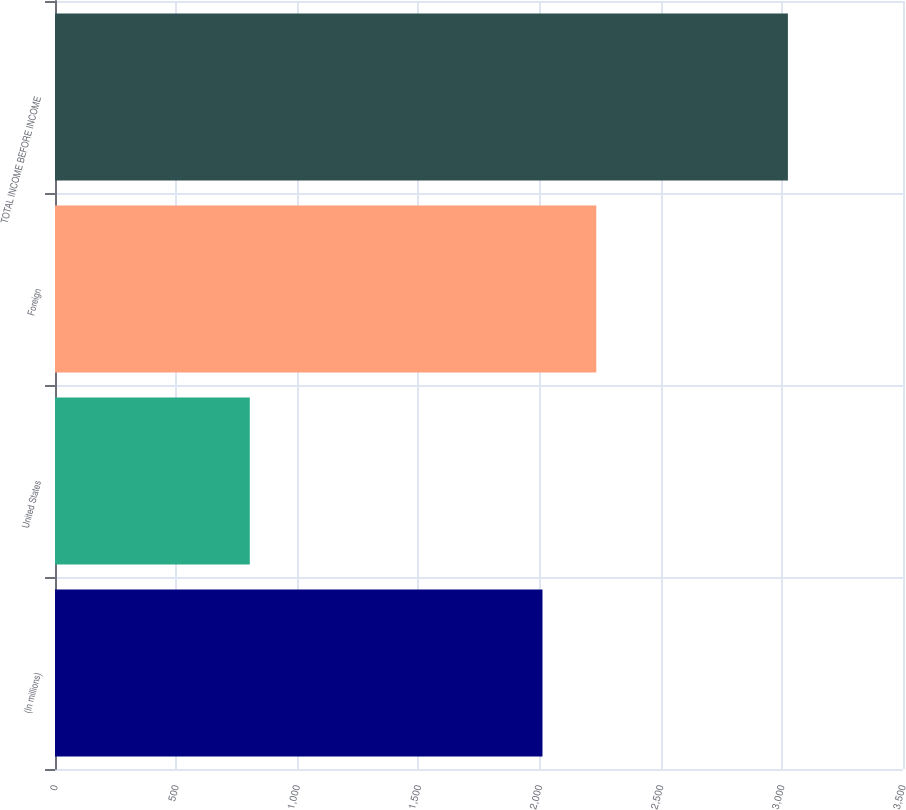Convert chart to OTSL. <chart><loc_0><loc_0><loc_500><loc_500><bar_chart><fcel>(In millions)<fcel>United States<fcel>Foreign<fcel>TOTAL INCOME BEFORE INCOME<nl><fcel>2012<fcel>804<fcel>2234.1<fcel>3025<nl></chart> 